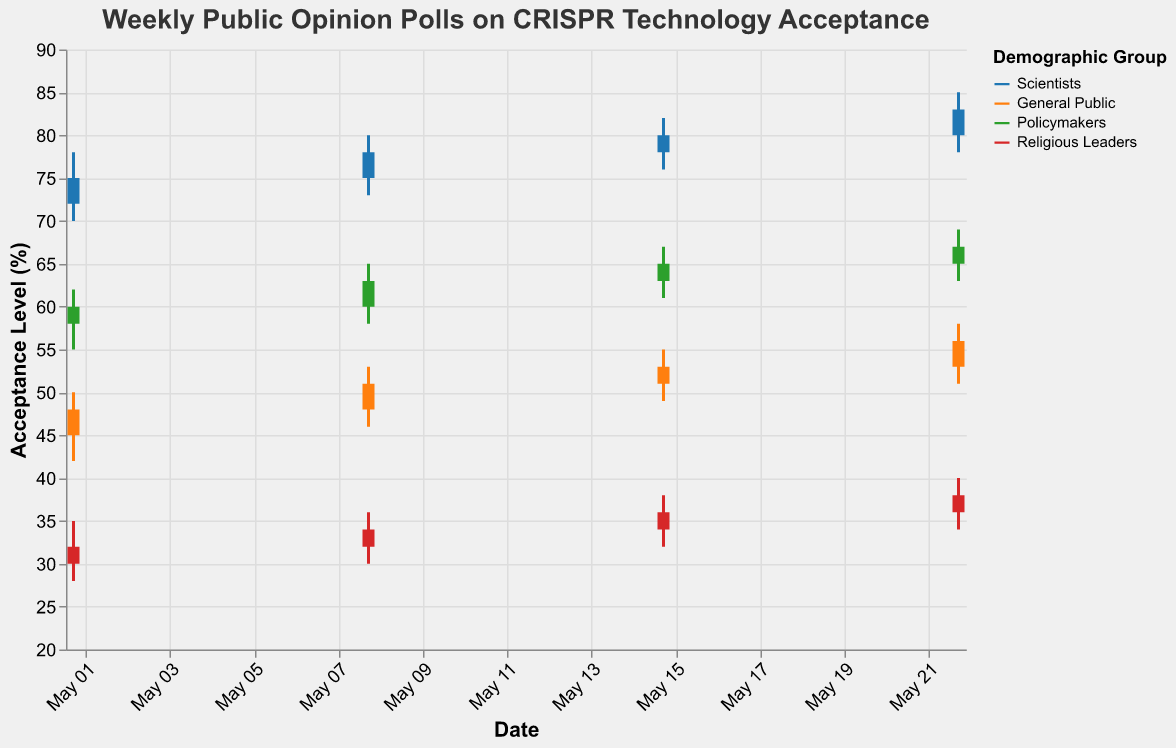Which demographic group consistently has the highest acceptance level of CRISPR technology? Observing the Close prices of the different groups across all dates, Scientists have the highest acceptance levels on every date.
Answer: Scientists What trend do you observe for the General Public's acceptance level from May 1 to May 22? The General Public's acceptance level is increasing steadily: May 1 (48), May 8 (51), May 15 (53), and May 22 (56).
Answer: Increasing What is the highest acceptance level recorded for Religious Leaders within the given time frame? The highest recorded acceptance level for Religious Leaders is the High value on May 22, which is 40.
Answer: 40 Which group shows the smallest range of acceptance levels (High - Low) throughout the survey period? Calculating the range (High - Low) for each group across all dates, Policymakers show the smallest range of 4: 62-58, 65-60, 67-63, 69-65.
Answer: Policymakers By how many percentage points did the acceptance level of Scientists increase from May 1 to May 22? The acceptance level for Scientists on May 1 is 75 and on May 22 is 83. The increase is 83 - 75 = 8 percentage points.
Answer: 8 Which group had a closing acceptance level of 34 on any given date? Observing the Close values for all dates, the Religious Leaders had a closing acceptance level of 34 on May 8.
Answer: Religious Leaders How much did the acceptance level of Policymakers change from May 8 to May 15? The Close value for Policymakers on May 8 was 63, and on May 15 it was 65. The change is 65 - 63 = 2 percentage points.
Answer: 2 Which group shows the highest variability (difference between High and Low values) on May 8? On May 8, the differences between High and Low values for each group are: Scientists (80-73=7), General Public (53-46=7), Policymakers (65-58=7), Religious Leaders (36-30=6). Hence, Scientists, General Public, and Policymakers show the highest variability of 7.
Answer: Scientists, General Public, Policymakers On May 15, which group had the lowest open acceptance level? Observing the Open values for May 15, the lowest value is for Religious Leaders at 34.
Answer: Religious Leaders What was the closing acceptance level of the General Public on May 22? Observing the Close value for the General Public on May 22, it is 56.
Answer: 56 